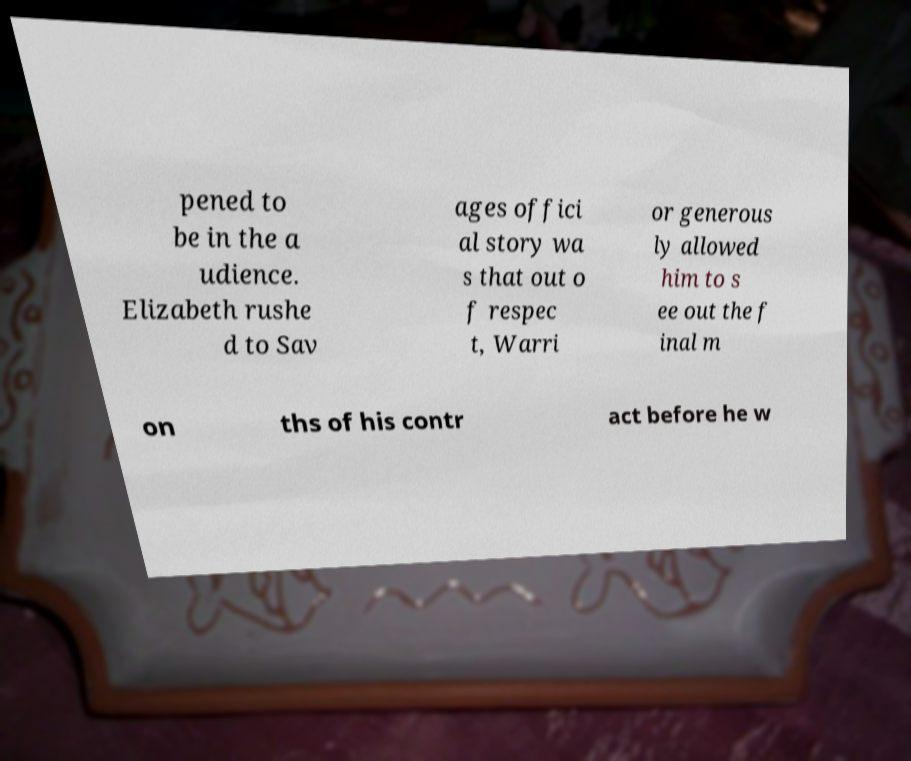Can you read and provide the text displayed in the image?This photo seems to have some interesting text. Can you extract and type it out for me? pened to be in the a udience. Elizabeth rushe d to Sav ages offici al story wa s that out o f respec t, Warri or generous ly allowed him to s ee out the f inal m on ths of his contr act before he w 